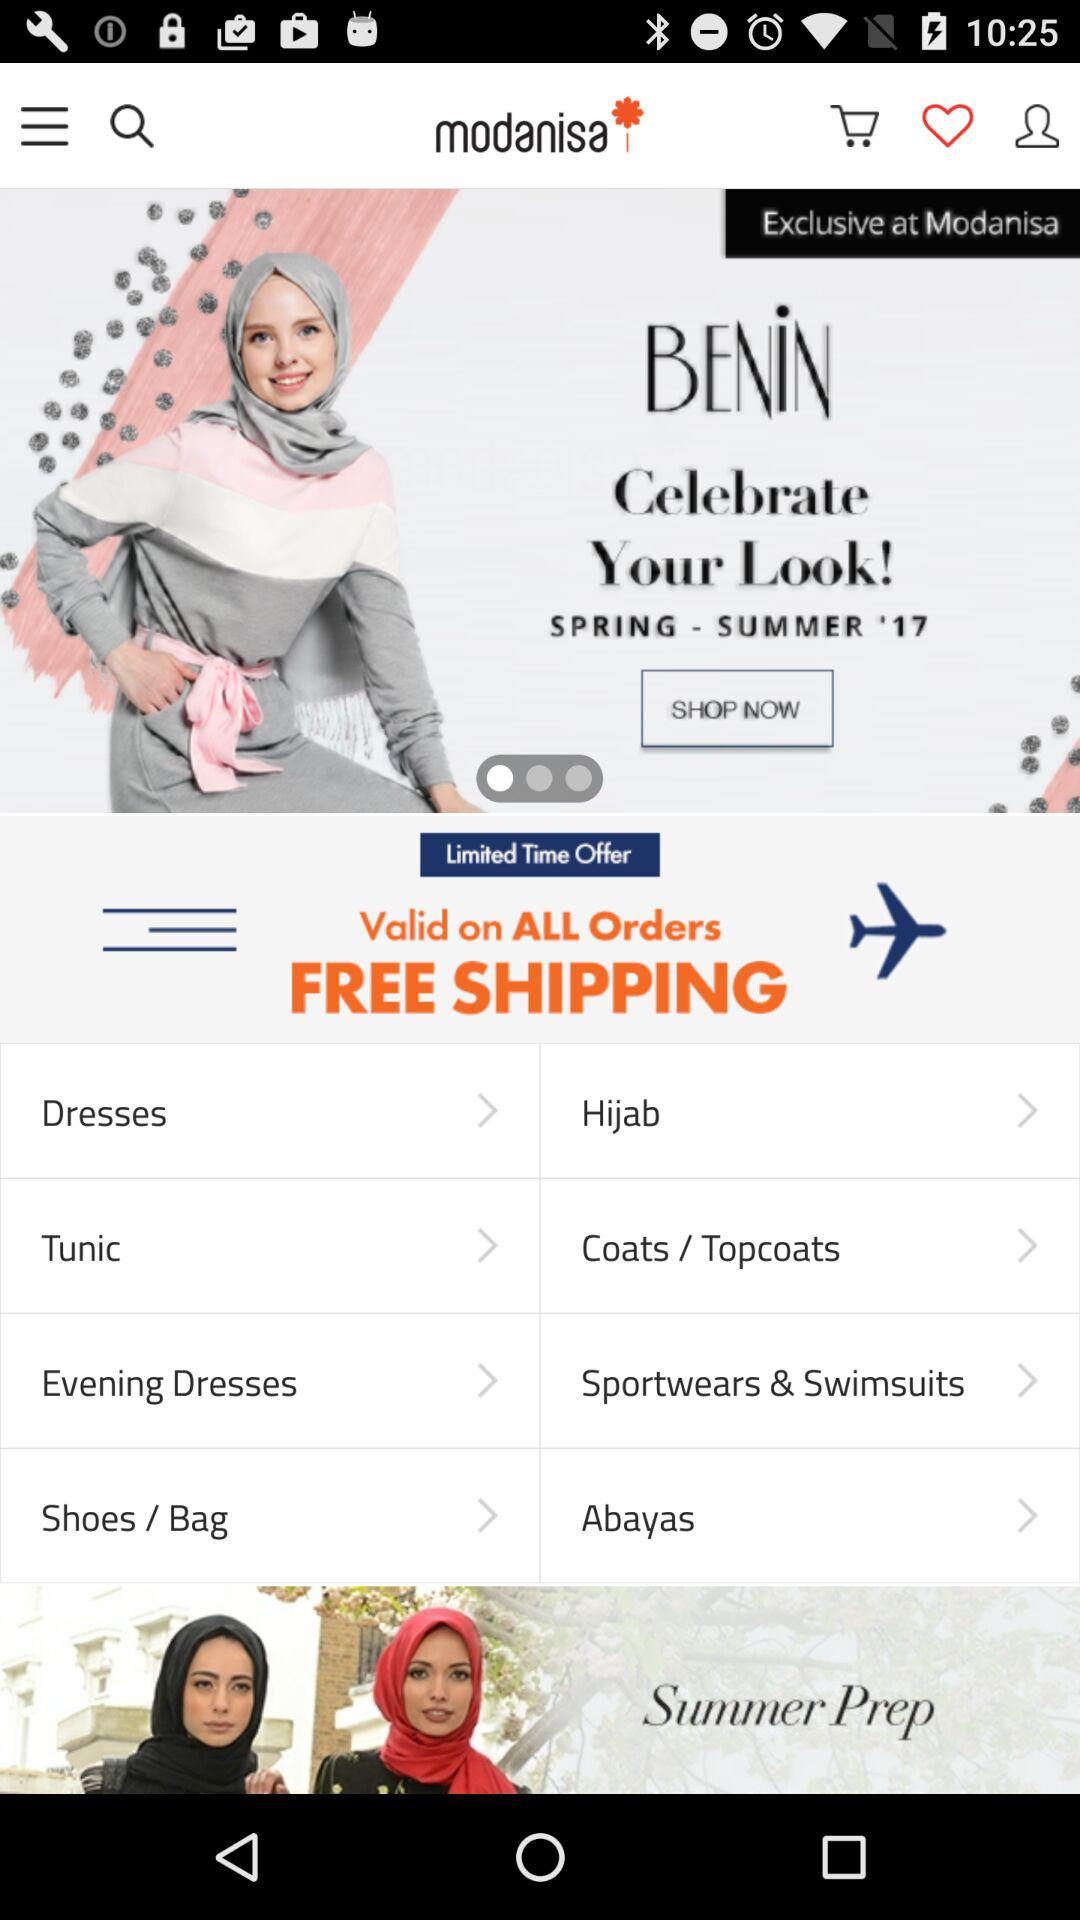What is the app name? The app name is "modanisa". 